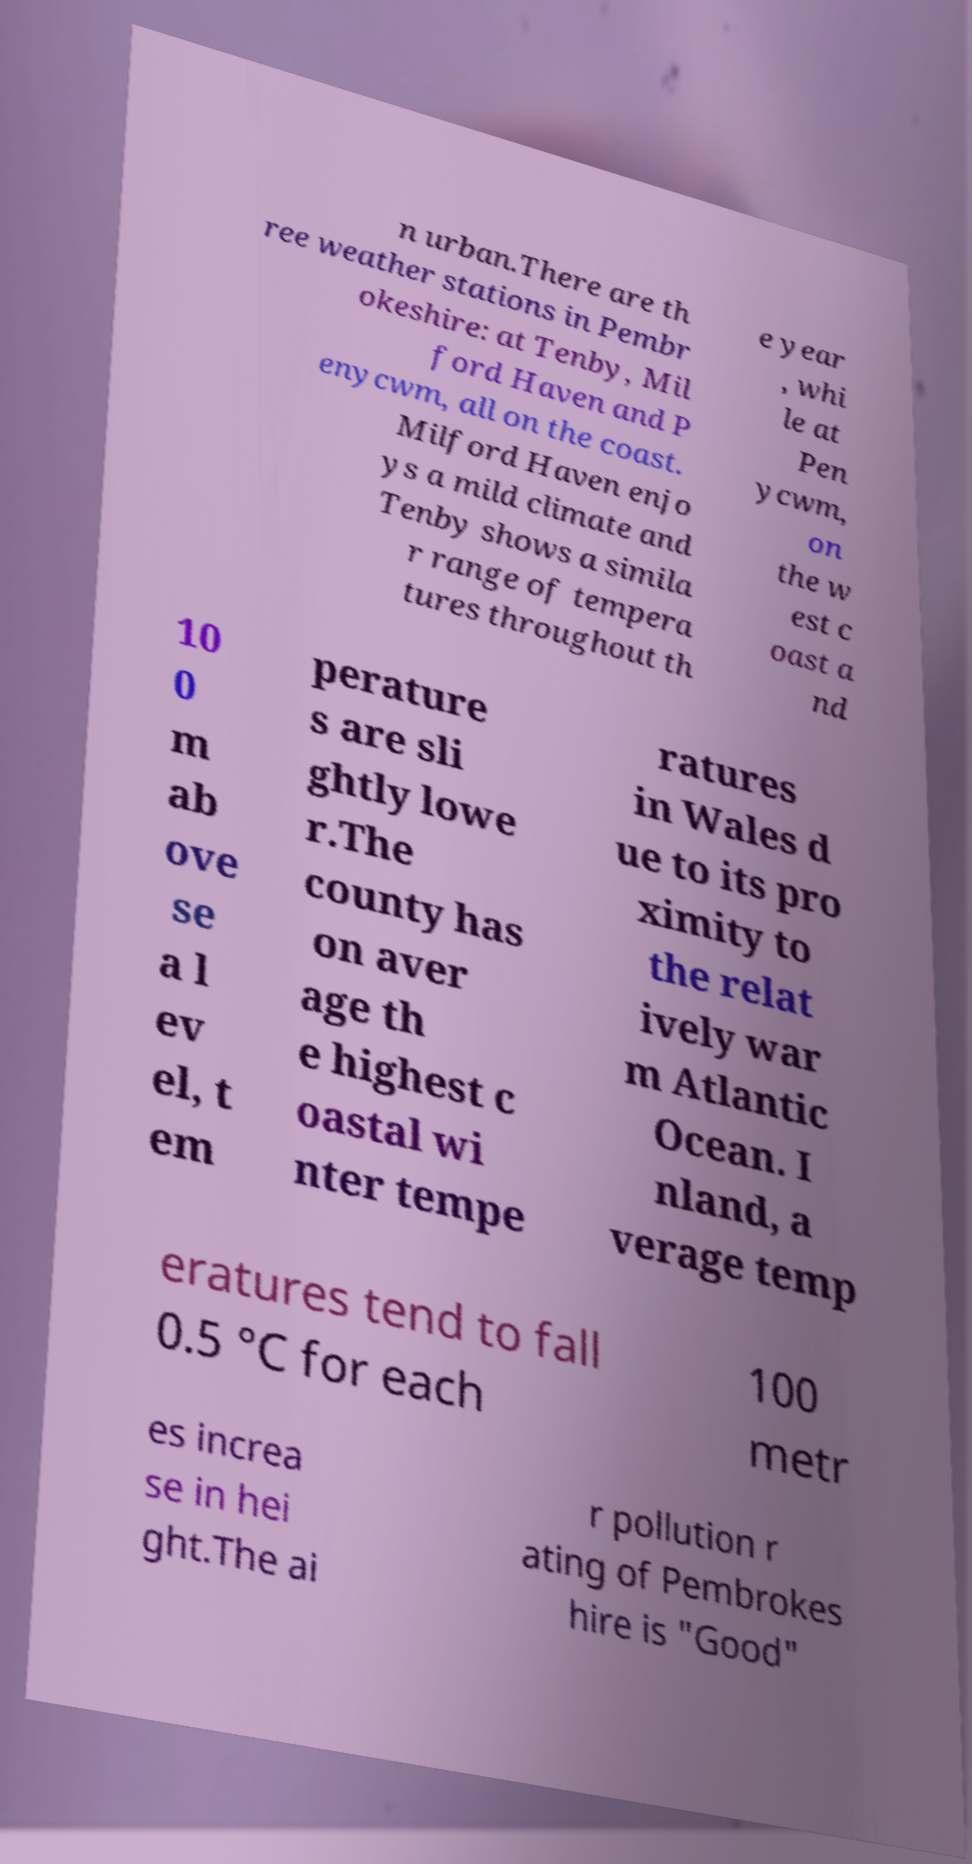For documentation purposes, I need the text within this image transcribed. Could you provide that? n urban.There are th ree weather stations in Pembr okeshire: at Tenby, Mil ford Haven and P enycwm, all on the coast. Milford Haven enjo ys a mild climate and Tenby shows a simila r range of tempera tures throughout th e year , whi le at Pen ycwm, on the w est c oast a nd 10 0 m ab ove se a l ev el, t em perature s are sli ghtly lowe r.The county has on aver age th e highest c oastal wi nter tempe ratures in Wales d ue to its pro ximity to the relat ively war m Atlantic Ocean. I nland, a verage temp eratures tend to fall 0.5 °C for each 100 metr es increa se in hei ght.The ai r pollution r ating of Pembrokes hire is "Good" 